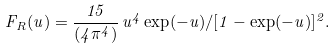Convert formula to latex. <formula><loc_0><loc_0><loc_500><loc_500>F _ { R } ( u ) = \frac { 1 5 } { ( 4 \pi ^ { 4 } ) } \, u ^ { 4 } \exp ( - u ) / [ 1 - \exp ( - u ) ] ^ { 2 } .</formula> 